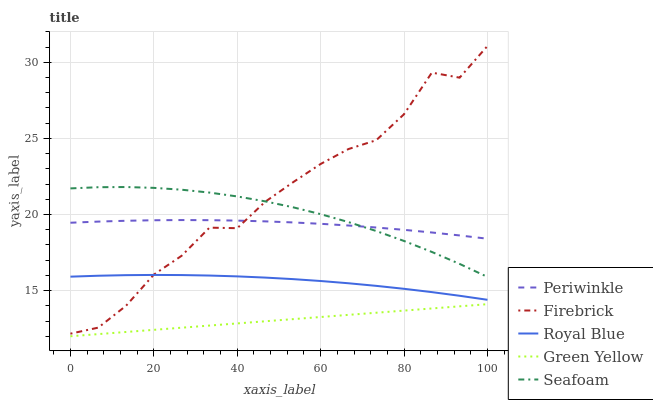Does Green Yellow have the minimum area under the curve?
Answer yes or no. Yes. Does Firebrick have the maximum area under the curve?
Answer yes or no. Yes. Does Firebrick have the minimum area under the curve?
Answer yes or no. No. Does Green Yellow have the maximum area under the curve?
Answer yes or no. No. Is Green Yellow the smoothest?
Answer yes or no. Yes. Is Firebrick the roughest?
Answer yes or no. Yes. Is Firebrick the smoothest?
Answer yes or no. No. Is Green Yellow the roughest?
Answer yes or no. No. Does Green Yellow have the lowest value?
Answer yes or no. Yes. Does Firebrick have the lowest value?
Answer yes or no. No. Does Firebrick have the highest value?
Answer yes or no. Yes. Does Green Yellow have the highest value?
Answer yes or no. No. Is Royal Blue less than Periwinkle?
Answer yes or no. Yes. Is Royal Blue greater than Green Yellow?
Answer yes or no. Yes. Does Firebrick intersect Royal Blue?
Answer yes or no. Yes. Is Firebrick less than Royal Blue?
Answer yes or no. No. Is Firebrick greater than Royal Blue?
Answer yes or no. No. Does Royal Blue intersect Periwinkle?
Answer yes or no. No. 